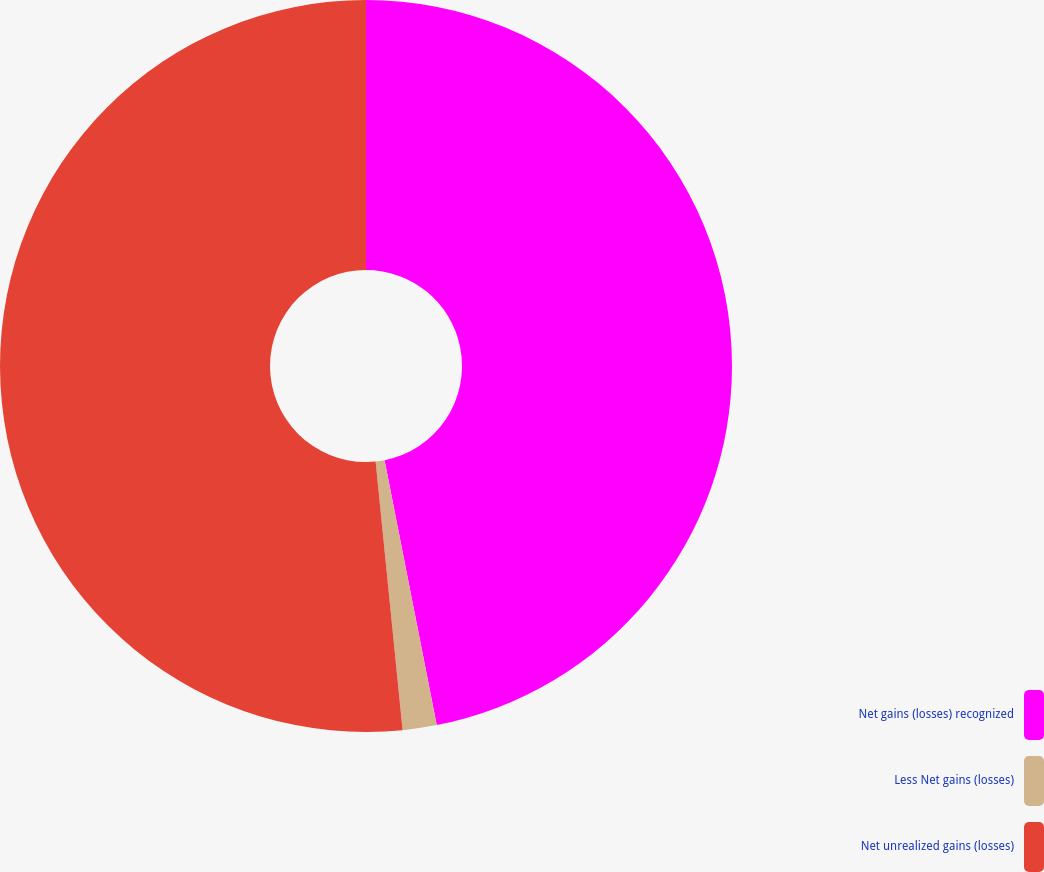Convert chart. <chart><loc_0><loc_0><loc_500><loc_500><pie_chart><fcel>Net gains (losses) recognized<fcel>Less Net gains (losses)<fcel>Net unrealized gains (losses)<nl><fcel>46.9%<fcel>1.5%<fcel>51.59%<nl></chart> 